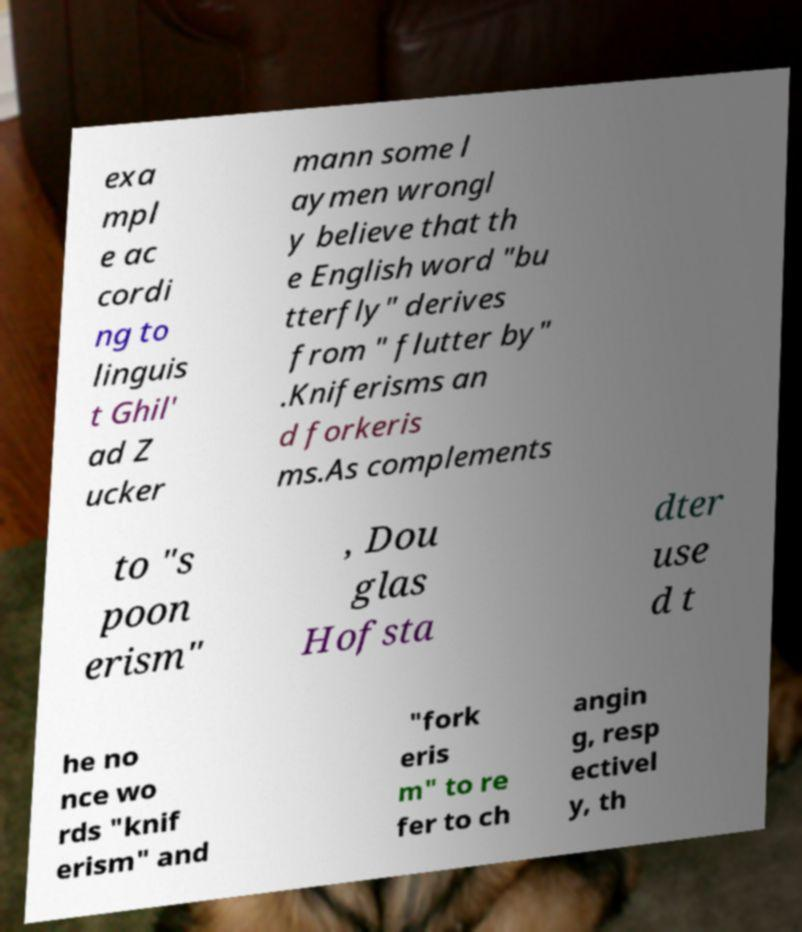Can you read and provide the text displayed in the image?This photo seems to have some interesting text. Can you extract and type it out for me? exa mpl e ac cordi ng to linguis t Ghil' ad Z ucker mann some l aymen wrongl y believe that th e English word "bu tterfly" derives from " flutter by" .Kniferisms an d forkeris ms.As complements to "s poon erism" , Dou glas Hofsta dter use d t he no nce wo rds "knif erism" and "fork eris m" to re fer to ch angin g, resp ectivel y, th 